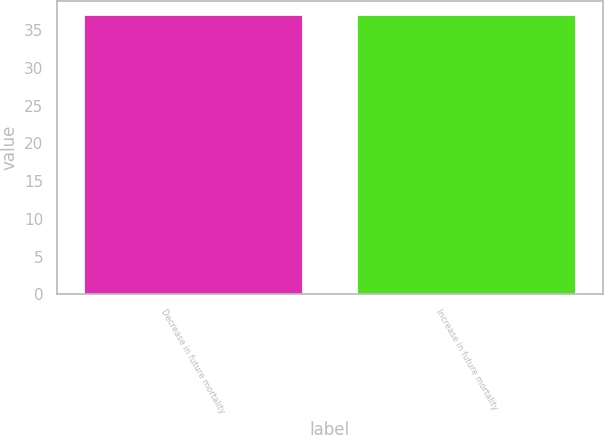Convert chart to OTSL. <chart><loc_0><loc_0><loc_500><loc_500><bar_chart><fcel>Decrease in future mortality<fcel>Increase in future mortality<nl><fcel>37<fcel>37.1<nl></chart> 